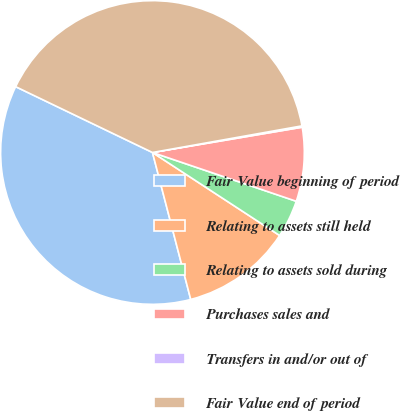Convert chart to OTSL. <chart><loc_0><loc_0><loc_500><loc_500><pie_chart><fcel>Fair Value beginning of period<fcel>Relating to assets still held<fcel>Relating to assets sold during<fcel>Purchases sales and<fcel>Transfers in and/or out of<fcel>Fair Value end of period<nl><fcel>36.19%<fcel>11.74%<fcel>4.0%<fcel>7.87%<fcel>0.14%<fcel>40.06%<nl></chart> 